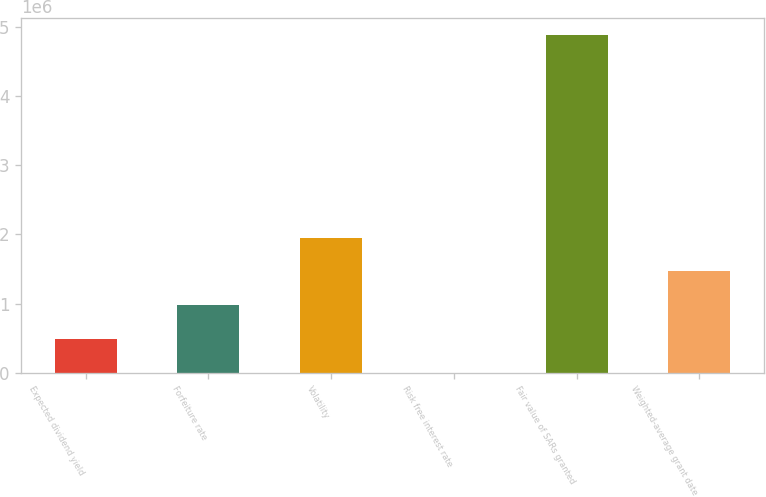Convert chart to OTSL. <chart><loc_0><loc_0><loc_500><loc_500><bar_chart><fcel>Expected dividend yield<fcel>Forfeiture rate<fcel>Volatility<fcel>Risk free interest rate<fcel>Fair value of SARs granted<fcel>Weighted-average grant date<nl><fcel>488402<fcel>976801<fcel>1.9536e+06<fcel>1.73<fcel>4.884e+06<fcel>1.4652e+06<nl></chart> 